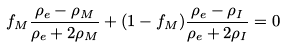Convert formula to latex. <formula><loc_0><loc_0><loc_500><loc_500>f _ { M } \frac { \rho _ { e } - \rho _ { M } } { \rho _ { e } + 2 \rho _ { M } } + ( 1 - f _ { M } ) \frac { \rho _ { e } - \rho _ { I } } { \rho _ { e } + 2 \rho _ { I } } = 0</formula> 